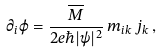Convert formula to latex. <formula><loc_0><loc_0><loc_500><loc_500>\partial _ { i } \varphi = \frac { \overline { M } } { 2 e \hbar { | } \psi | ^ { 2 } } \, m _ { i k } \, j _ { k } \, ,</formula> 